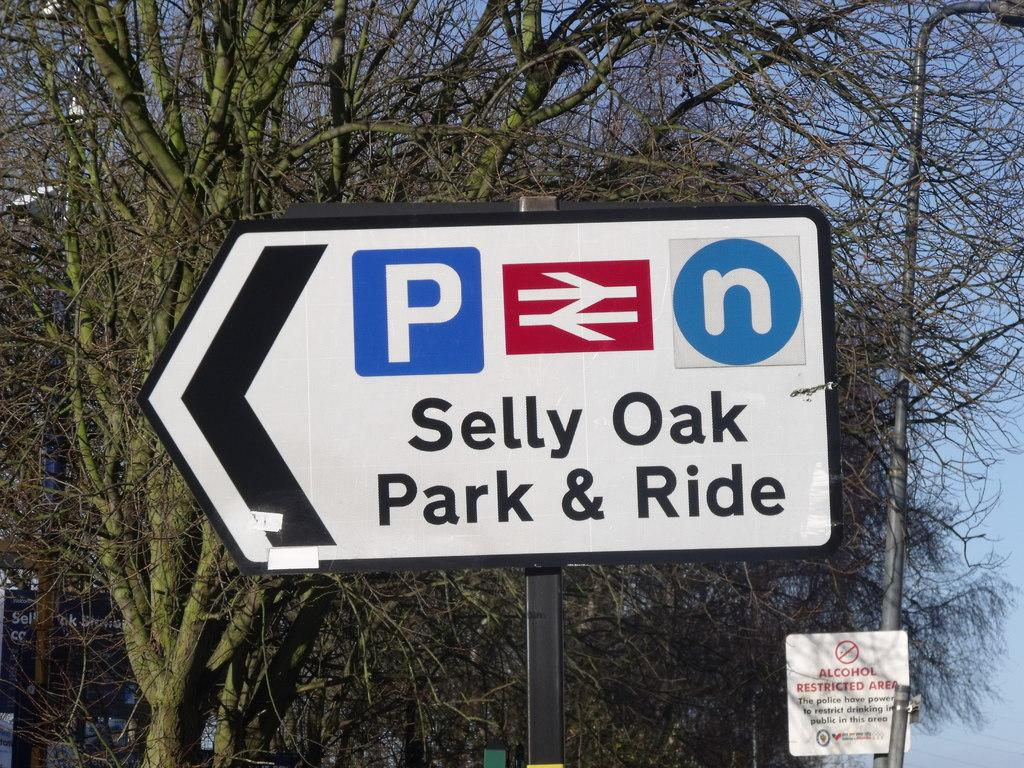<image>
Offer a succinct explanation of the picture presented. A white sign with an arrow pointing left towards Selly Oak Park and Ride. 